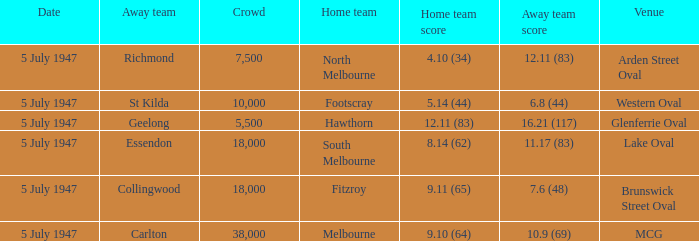What did the home team score when the away team scored 12.11 (83)? 4.10 (34). 